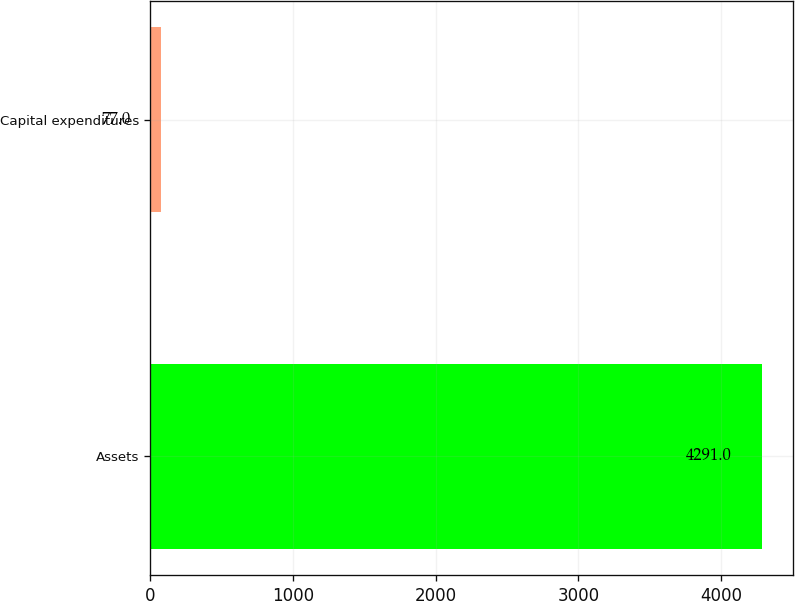Convert chart. <chart><loc_0><loc_0><loc_500><loc_500><bar_chart><fcel>Assets<fcel>Capital expenditures<nl><fcel>4291<fcel>77<nl></chart> 